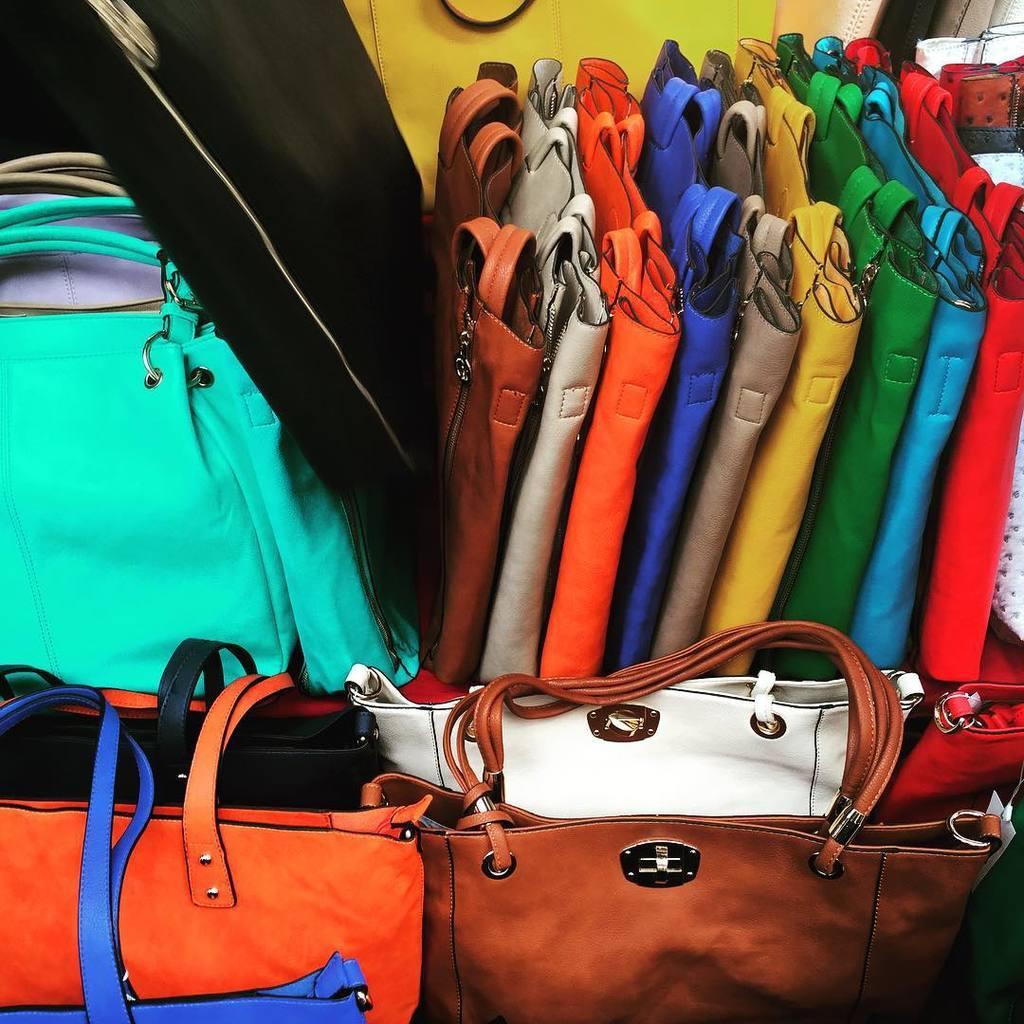How would you summarize this image in a sentence or two? In the image there are different colors of handbags are kept in an order. They are of different shapes and sizes. 